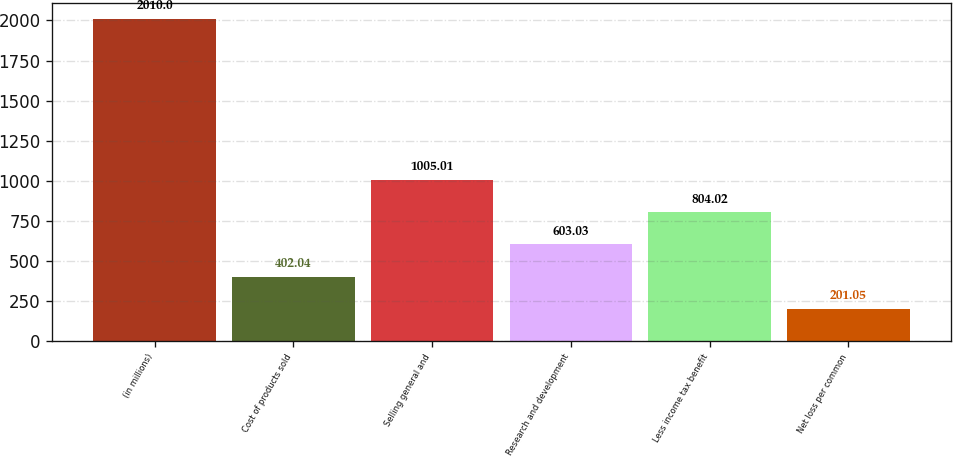Convert chart to OTSL. <chart><loc_0><loc_0><loc_500><loc_500><bar_chart><fcel>(in millions)<fcel>Cost of products sold<fcel>Selling general and<fcel>Research and development<fcel>Less income tax benefit<fcel>Net loss per common<nl><fcel>2010<fcel>402.04<fcel>1005.01<fcel>603.03<fcel>804.02<fcel>201.05<nl></chart> 